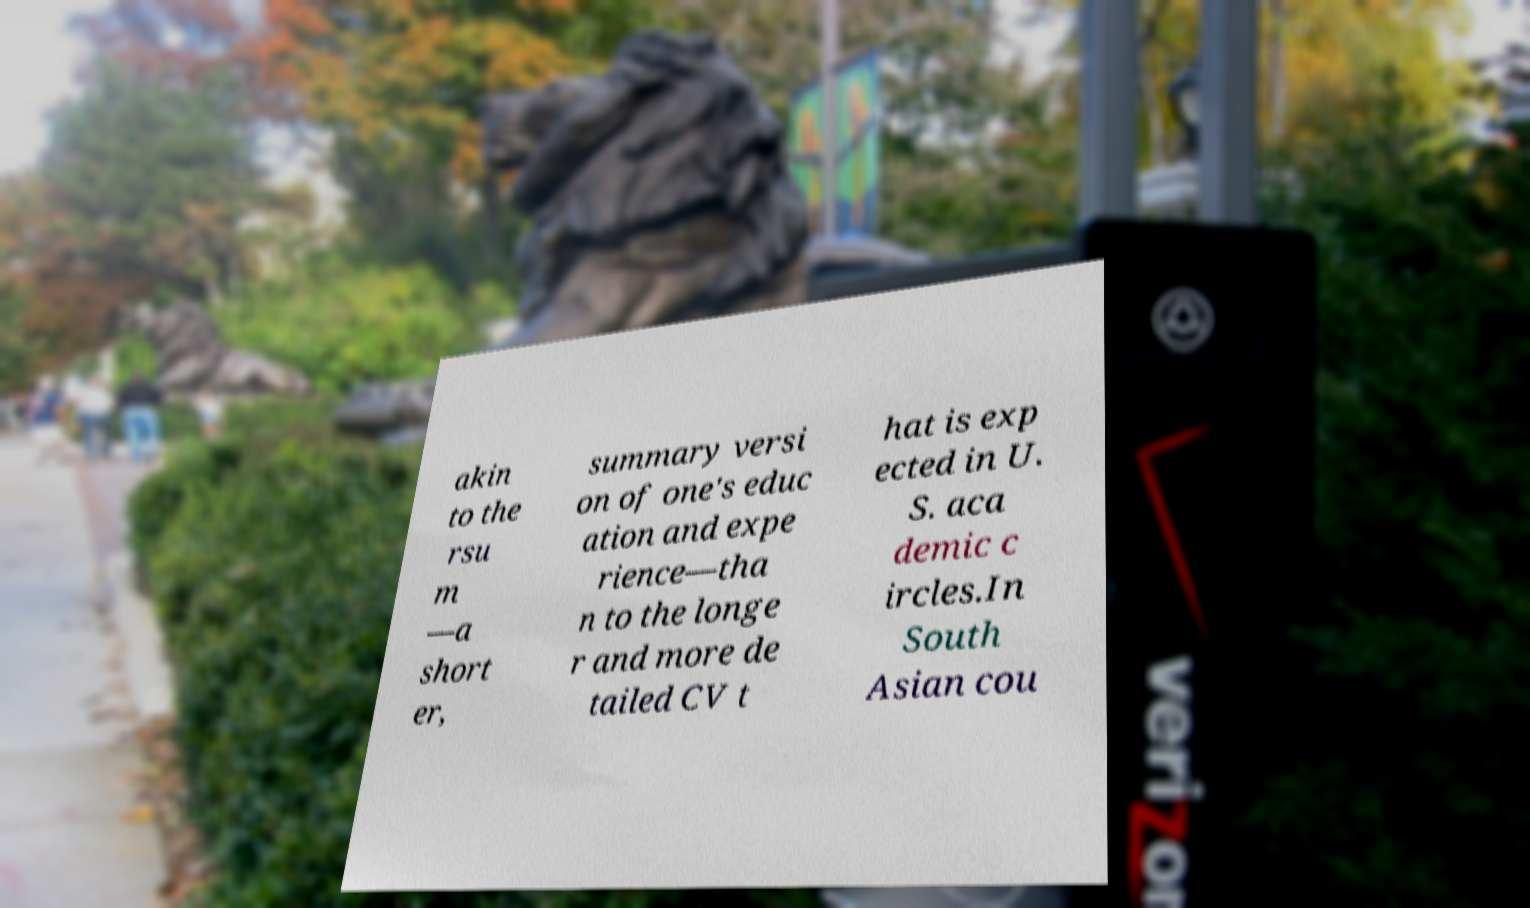What messages or text are displayed in this image? I need them in a readable, typed format. akin to the rsu m —a short er, summary versi on of one's educ ation and expe rience—tha n to the longe r and more de tailed CV t hat is exp ected in U. S. aca demic c ircles.In South Asian cou 